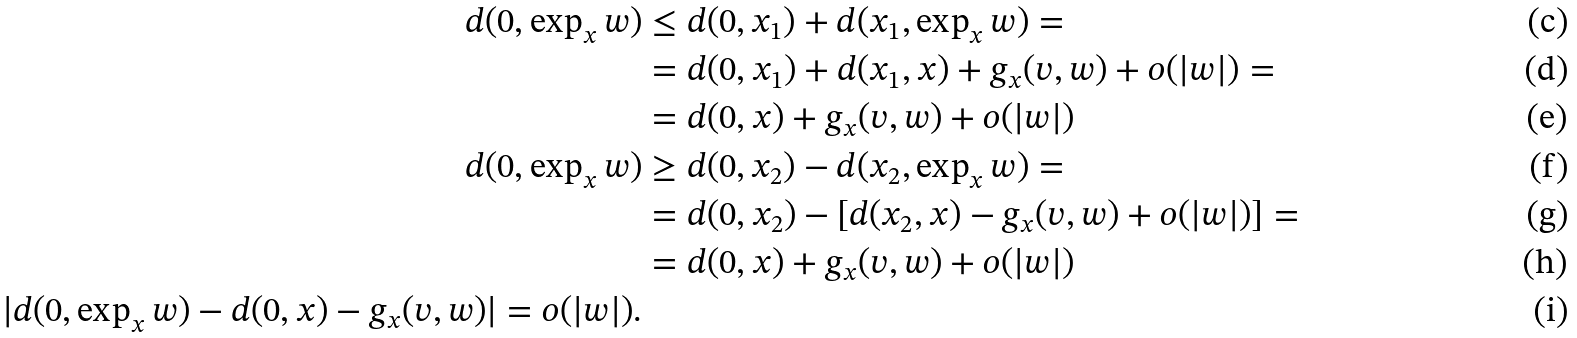Convert formula to latex. <formula><loc_0><loc_0><loc_500><loc_500>d ( 0 , \exp _ { x } w ) & \leq d ( 0 , x _ { 1 } ) + d ( x _ { 1 } , \exp _ { x } w ) = \\ & = d ( 0 , x _ { 1 } ) + d ( x _ { 1 } , x ) + g _ { x } ( v , w ) + o ( | w | ) = \\ & = d ( 0 , x ) + g _ { x } ( v , w ) + o ( | w | ) \\ d ( 0 , \exp _ { x } w ) & \geq d ( 0 , x _ { 2 } ) - d ( x _ { 2 } , \exp _ { x } w ) = \\ & = d ( 0 , x _ { 2 } ) - \left [ d ( x _ { 2 } , x ) - g _ { x } ( v , w ) + o ( | w | ) \right ] = \\ & = d ( 0 , x ) + g _ { x } ( v , w ) + o ( | w | ) \\ | d ( 0 , \exp _ { x } w ) - d ( 0 , x ) - g _ { x } ( v , w ) | = o ( | w | ) .</formula> 